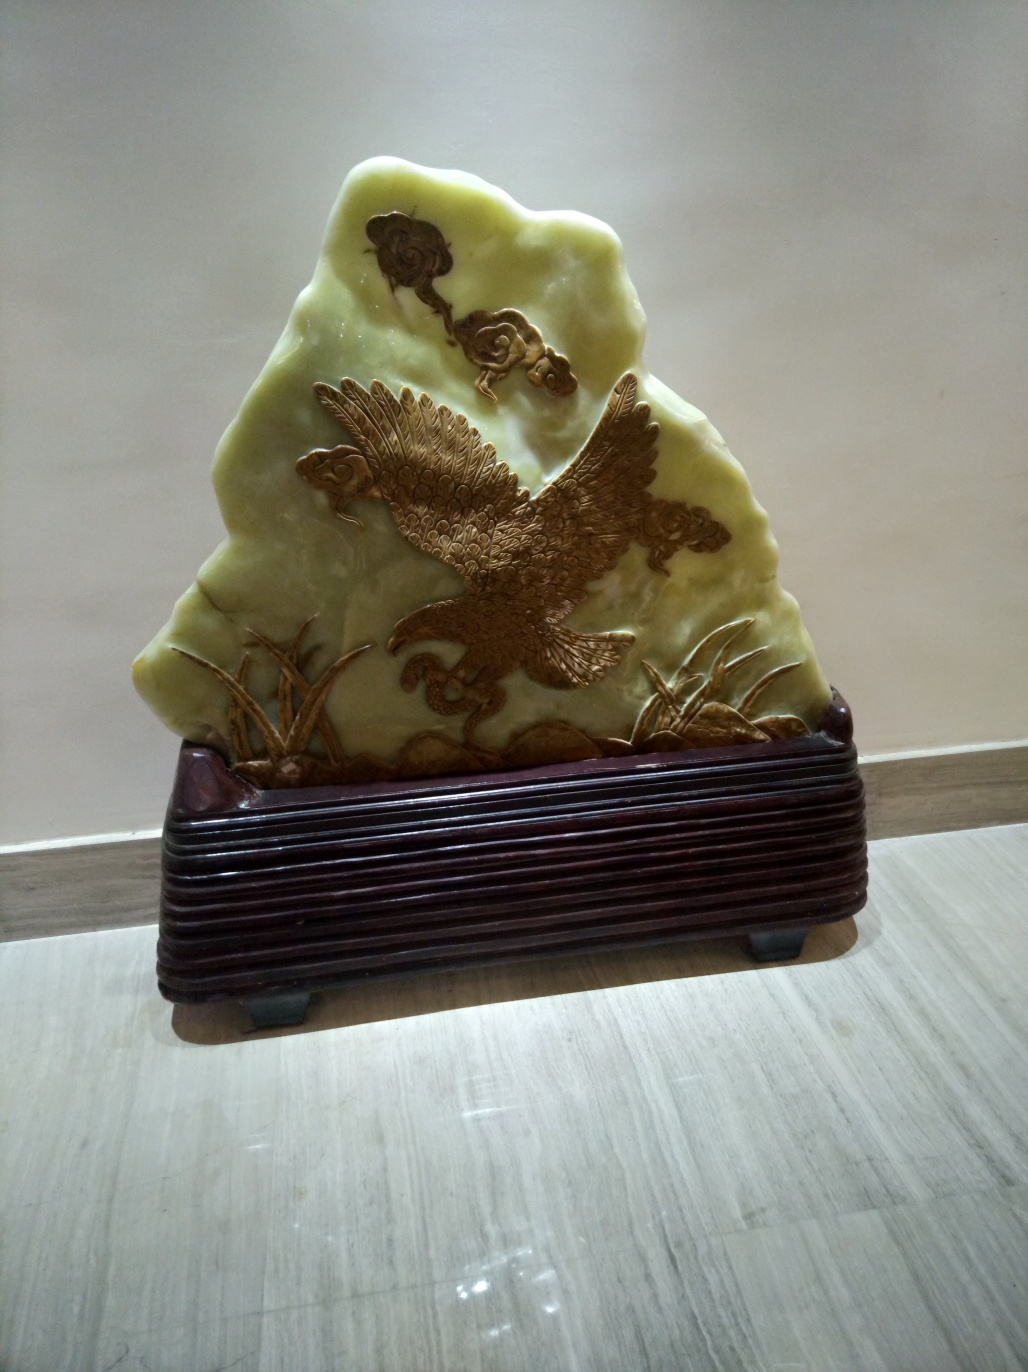What might be the cultural significance or symbolism of the eagle in this artifact? The eagle is often regarded as a symbol of power, freedom, and transcendence. In various cultures, it represents a connection to divine forces due to its ability to soar at high altitudes. The depiction of an eagle in this artifact may signify the desire to embody its attributes or to pay homage to its symbolic role within a specific cultural context. 